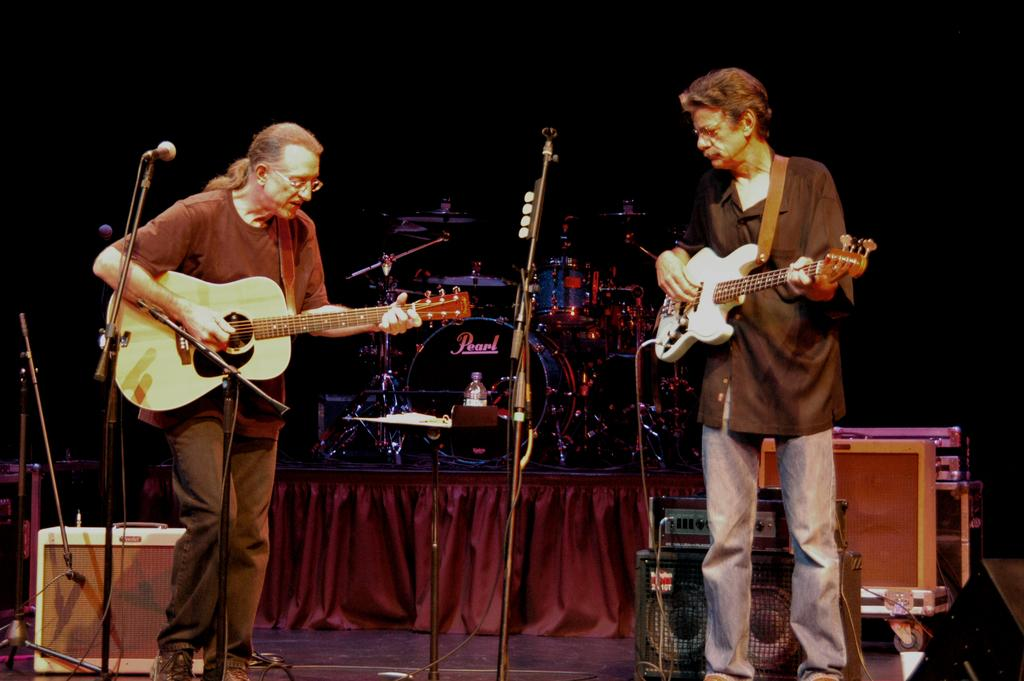How many people are in the image? There are two people in the image. What are the two people doing? The two people are standing and holding guitars in their hands. What other musical instruments can be seen in the image? There are microphones and drums in the image. What type of honey is being served on the pies in the image? There are no pies or honey present in the image; it features two people holding guitars and other musical instruments. Can you tell me how many donkeys are visible in the image? There are no donkeys present in the image. 